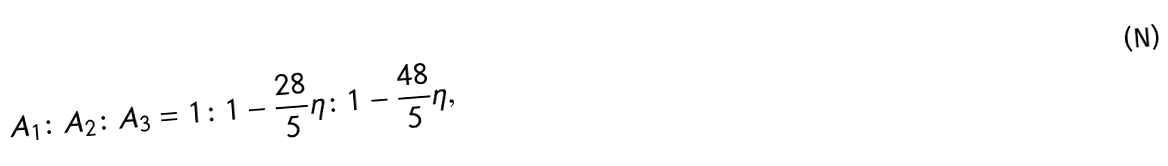<formula> <loc_0><loc_0><loc_500><loc_500>A _ { 1 } \colon A _ { 2 } \colon A _ { 3 } = 1 \colon 1 - \frac { 2 8 } { 5 } \eta \colon 1 - \frac { 4 8 } { 5 } \eta ,</formula> 